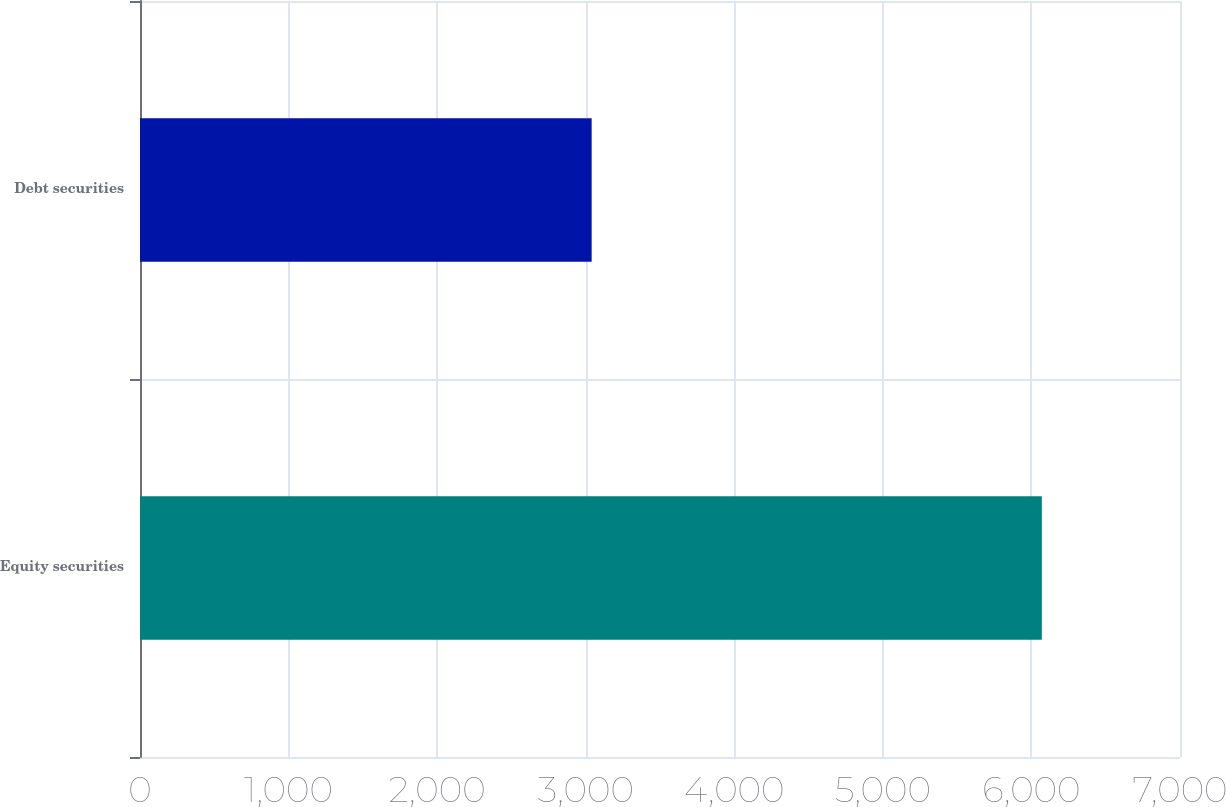Convert chart. <chart><loc_0><loc_0><loc_500><loc_500><bar_chart><fcel>Equity securities<fcel>Debt securities<nl><fcel>6070<fcel>3040<nl></chart> 